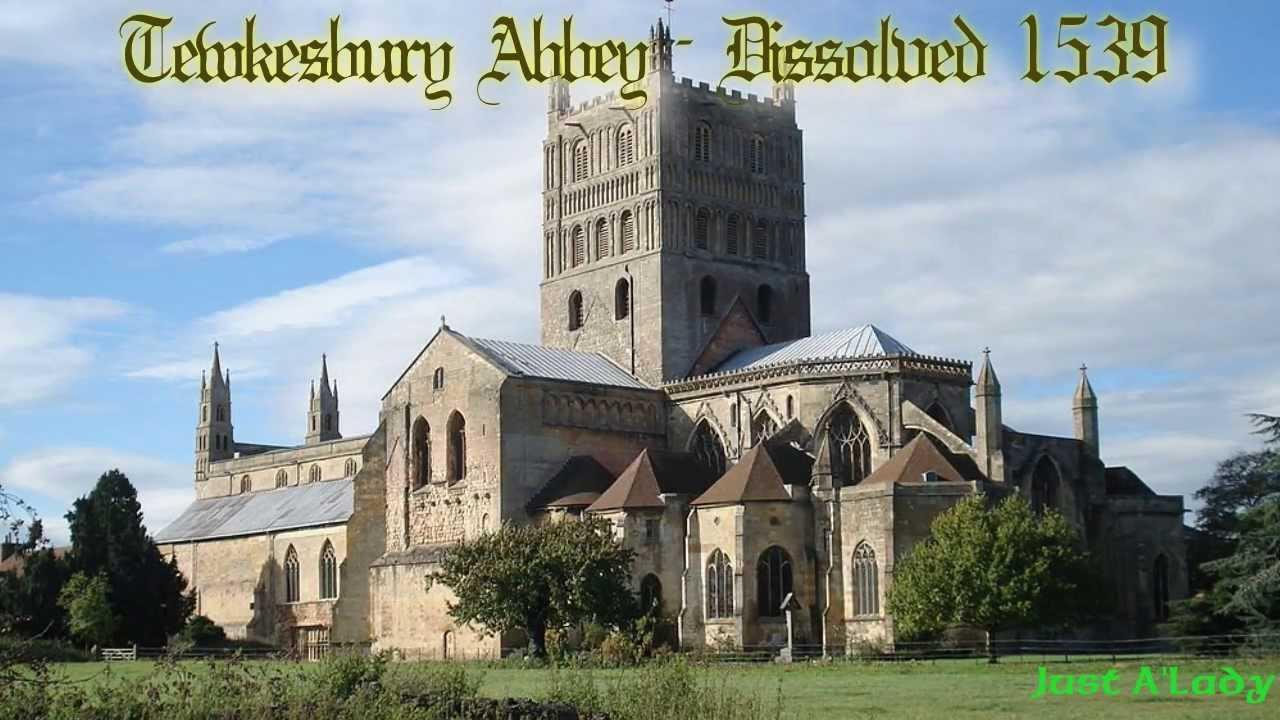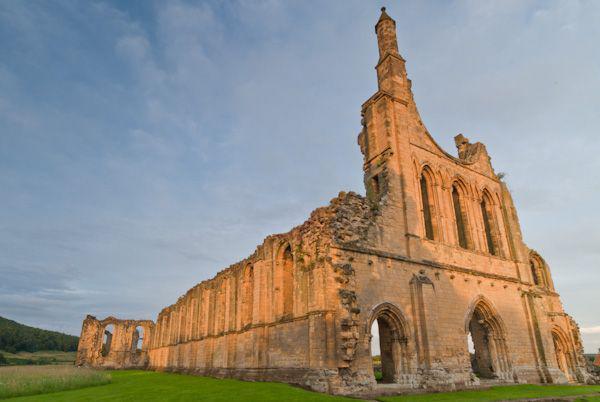The first image is the image on the left, the second image is the image on the right. Assess this claim about the two images: "There are no trees near any of the buidlings pictured.". Correct or not? Answer yes or no. No. 